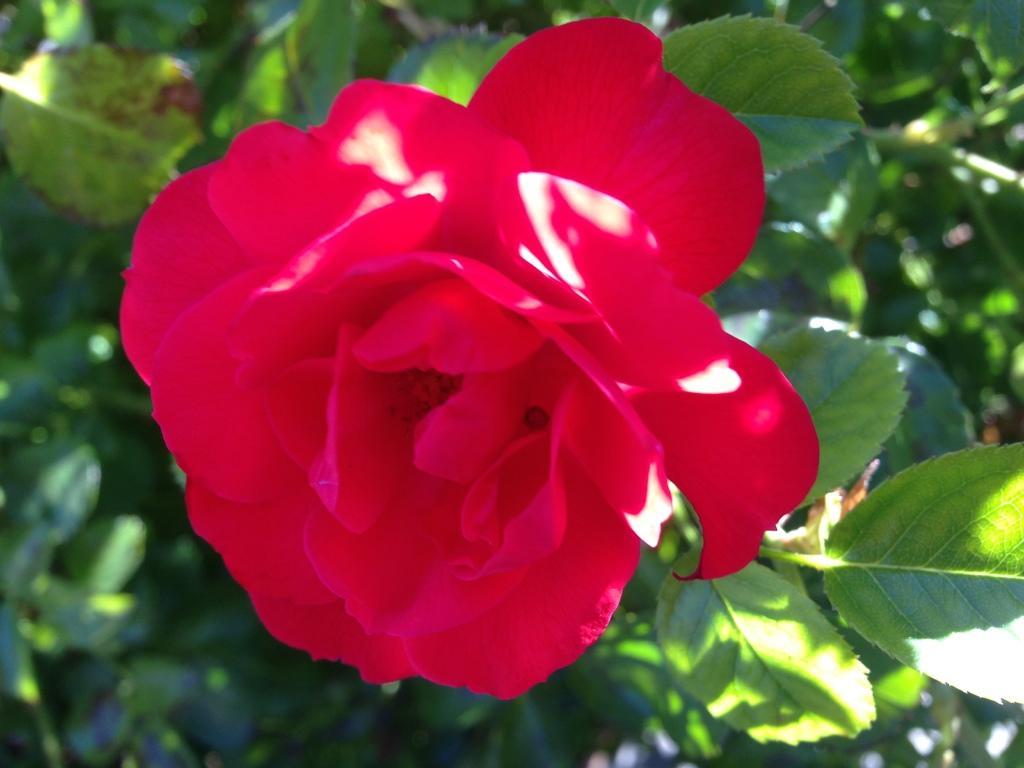Could you give a brief overview of what you see in this image? There is a rose flower on a stem. In the background it is green and blurred. 